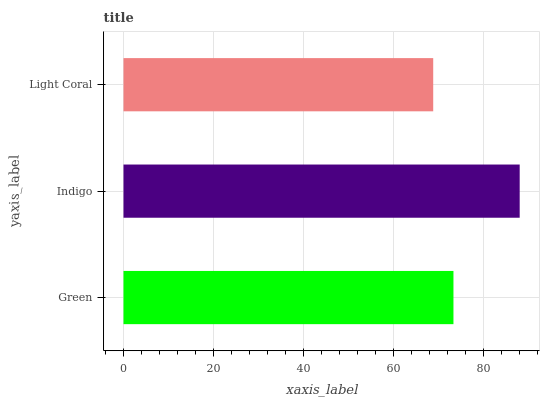Is Light Coral the minimum?
Answer yes or no. Yes. Is Indigo the maximum?
Answer yes or no. Yes. Is Indigo the minimum?
Answer yes or no. No. Is Light Coral the maximum?
Answer yes or no. No. Is Indigo greater than Light Coral?
Answer yes or no. Yes. Is Light Coral less than Indigo?
Answer yes or no. Yes. Is Light Coral greater than Indigo?
Answer yes or no. No. Is Indigo less than Light Coral?
Answer yes or no. No. Is Green the high median?
Answer yes or no. Yes. Is Green the low median?
Answer yes or no. Yes. Is Light Coral the high median?
Answer yes or no. No. Is Light Coral the low median?
Answer yes or no. No. 